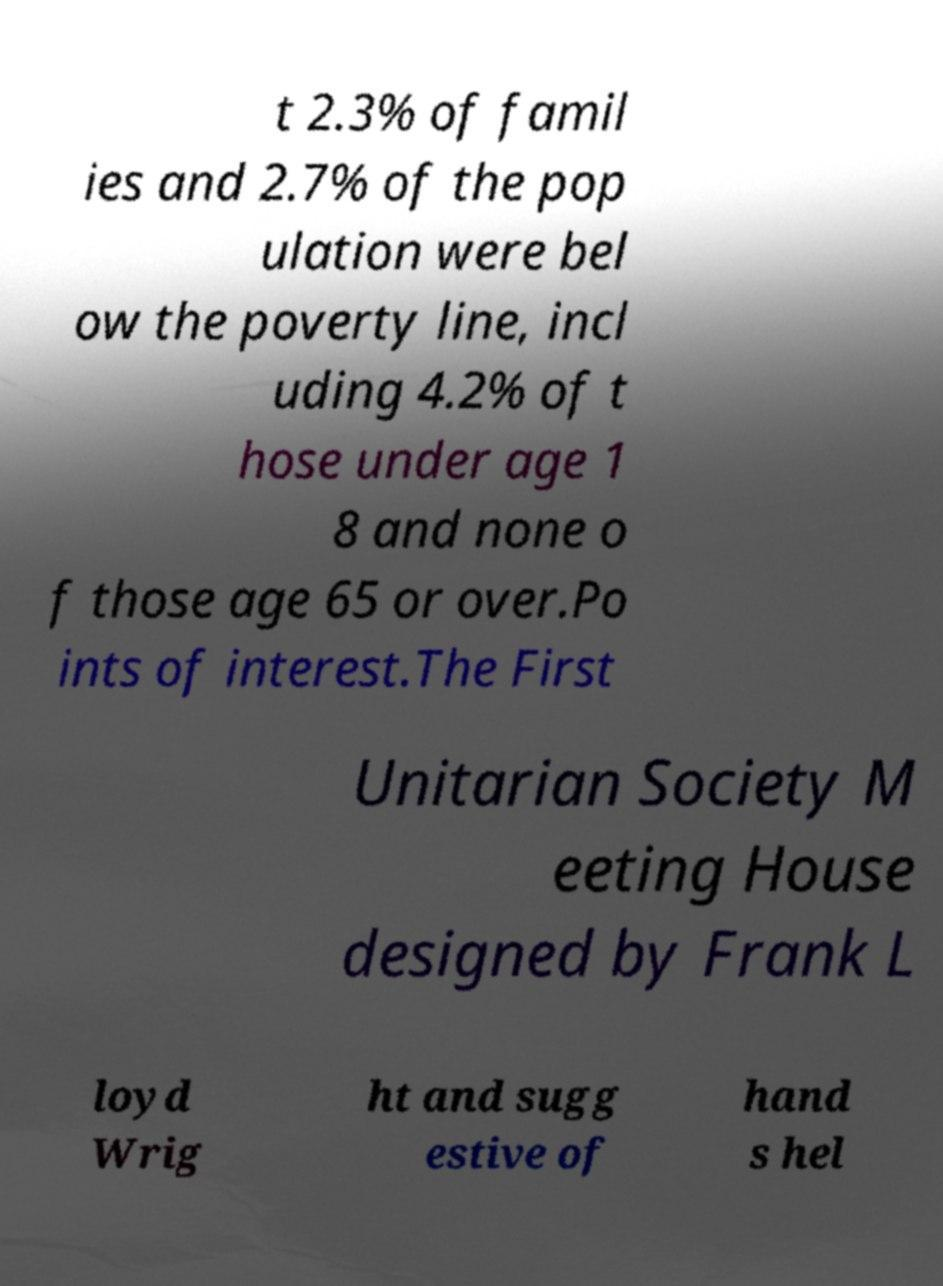Please identify and transcribe the text found in this image. t 2.3% of famil ies and 2.7% of the pop ulation were bel ow the poverty line, incl uding 4.2% of t hose under age 1 8 and none o f those age 65 or over.Po ints of interest.The First Unitarian Society M eeting House designed by Frank L loyd Wrig ht and sugg estive of hand s hel 